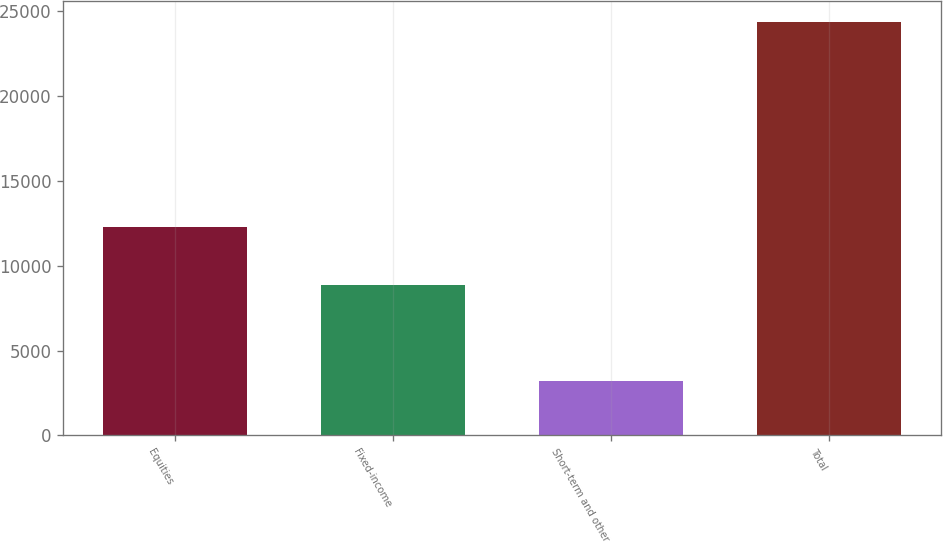Convert chart. <chart><loc_0><loc_0><loc_500><loc_500><bar_chart><fcel>Equities<fcel>Fixed-income<fcel>Short-term and other<fcel>Total<nl><fcel>12276<fcel>8885<fcel>3210<fcel>24371<nl></chart> 